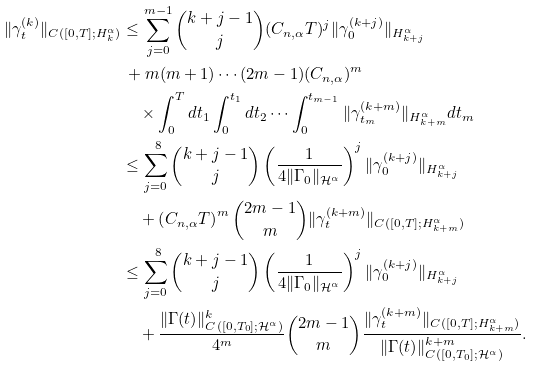<formula> <loc_0><loc_0><loc_500><loc_500>\| \gamma ^ { ( k ) } _ { t } \| _ { C ( [ 0 , T ] ; H ^ { \alpha } _ { k } ) } & \leq \sum _ { j = 0 } ^ { m - 1 } \binom { k + j - 1 } { j } ( C _ { n , \alpha } T ) ^ { j } \| \gamma ^ { ( k + j ) } _ { 0 } \| _ { H ^ { \alpha } _ { k + j } } \\ & \, + m ( m + 1 ) \cdots ( 2 m - 1 ) ( C _ { n , \alpha } ) ^ { m } \\ & \quad \times \int _ { 0 } ^ { T } d t _ { 1 } \int _ { 0 } ^ { t _ { 1 } } d t _ { 2 } \cdots \int _ { 0 } ^ { t _ { m - 1 } } \| \gamma ^ { ( k + m ) } _ { t _ { m } } \| _ { H ^ { \alpha } _ { k + m } } d t _ { m } \\ & \leq \sum _ { j = 0 } ^ { \ 8 } \binom { k + j - 1 } { j } \left ( \frac { 1 } { 4 \| \Gamma _ { 0 } \| _ { \mathcal { H } ^ { \alpha } } } \right ) ^ { j } \| \gamma ^ { ( k + j ) } _ { 0 } \| _ { H ^ { \alpha } _ { k + j } } \\ & \quad + \left ( C _ { n , \alpha } T \right ) ^ { m } \binom { 2 m - 1 } { m } \| \gamma ^ { ( k + m ) } _ { t } \| _ { C ( [ 0 , T ] ; H ^ { \alpha } _ { k + m } ) } \\ & \leq \sum _ { j = 0 } ^ { \ 8 } \binom { k + j - 1 } { j } \left ( \frac { 1 } { 4 \| \Gamma _ { 0 } \| _ { \mathcal { H } ^ { \alpha } } } \right ) ^ { j } \| \gamma ^ { ( k + j ) } _ { 0 } \| _ { H ^ { \alpha } _ { k + j } } \\ & \quad + \frac { \| \Gamma ( t ) \| ^ { k } _ { C ( [ 0 , T _ { 0 } ] ; \mathcal { H } ^ { \alpha } ) } } { 4 ^ { m } } \binom { 2 m - 1 } { m } \frac { \| \gamma ^ { ( k + m ) } _ { t } \| _ { C ( [ 0 , T ] ; H ^ { \alpha } _ { k + m } ) } } { \| \Gamma ( t ) \| ^ { k + m } _ { C ( [ 0 , T _ { 0 } ] ; \mathcal { H } ^ { \alpha } ) } } .</formula> 